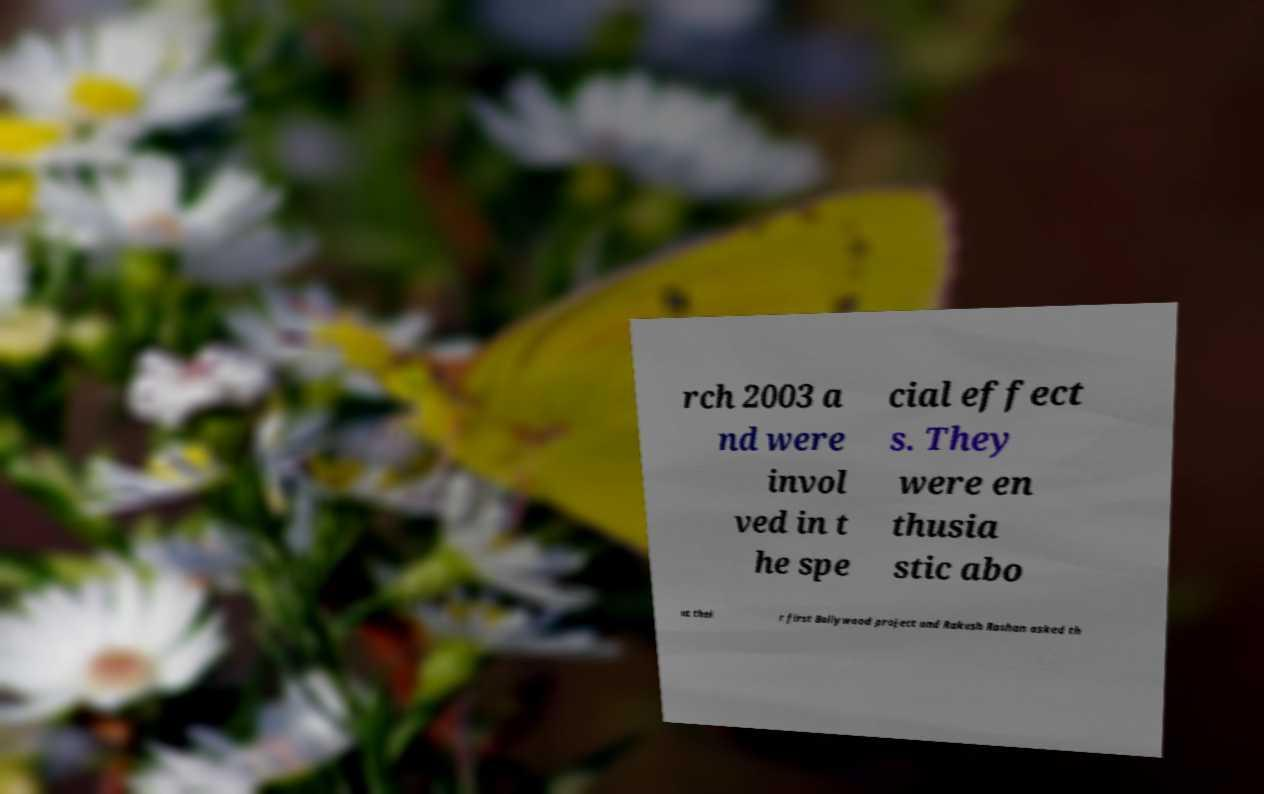What messages or text are displayed in this image? I need them in a readable, typed format. rch 2003 a nd were invol ved in t he spe cial effect s. They were en thusia stic abo ut thei r first Bollywood project and Rakesh Roshan asked th 